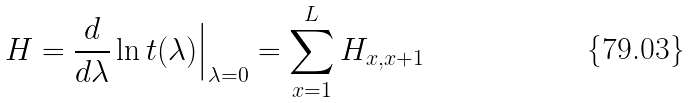<formula> <loc_0><loc_0><loc_500><loc_500>H = \frac { d } { d \lambda } \ln t ( \lambda ) \Big | _ { \lambda = 0 } = \sum _ { x = 1 } ^ { L } H _ { x , x + 1 }</formula> 